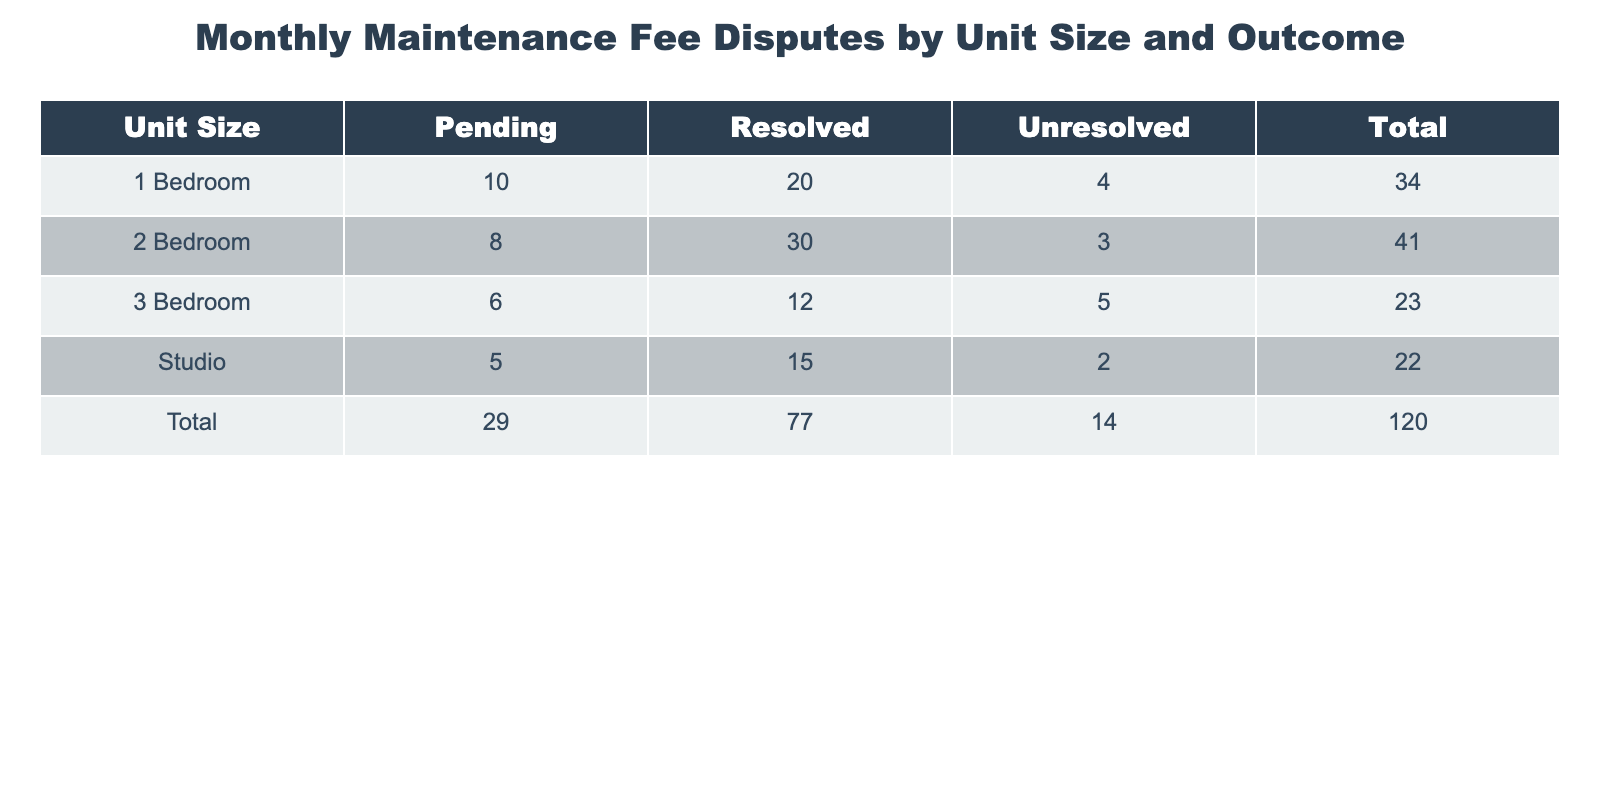What is the total count of resolved disputes for all unit sizes? To find the total count of resolved disputes, we look at the 'Resolved' column for each unit size. The counts are: Studio 15, 1 Bedroom 20, 2 Bedroom 30, and 3 Bedroom 12. Adding these gives 15 + 20 + 30 + 12 = 77.
Answer: 77 Which unit size has the highest number of unresolved disputes? We compare the counts in the 'Unresolved' column for each unit size: Studio has 2, 1 Bedroom has 4, 2 Bedroom has 3, and 3 Bedroom has 5. The highest count is 5 for the 3 Bedroom unit.
Answer: 3 Bedroom What percentage of disputes for 1 Bedroom units are pending? To find the percentage of pending disputes for 1 Bedroom units, we take the count of pending (10) and divide it by the total disputes for that size (20 resolved + 10 pending + 4 unresolved = 34). The calculation is (10/34) * 100, which gives approximately 29.41%.
Answer: Approximately 29.41% True or false: The total count of disputes across all unit sizes is 205. We calculate the total count by adding all disputes: Studio (22) + 1 Bedroom (34) + 2 Bedroom (41) + 3 Bedroom (23) equals 120. Since 120 does not equal 205, the statement is false.
Answer: False What is the average number of pending disputes across all unit sizes? We first identify the count of pending disputes: Studio 5, 1 Bedroom 10, 2 Bedroom 8, and 3 Bedroom 6. Total pending disputes = 5 + 10 + 8 + 6 = 29. There are 4 unit sizes, thus the average is 29/4 = 7.25.
Answer: 7.25 